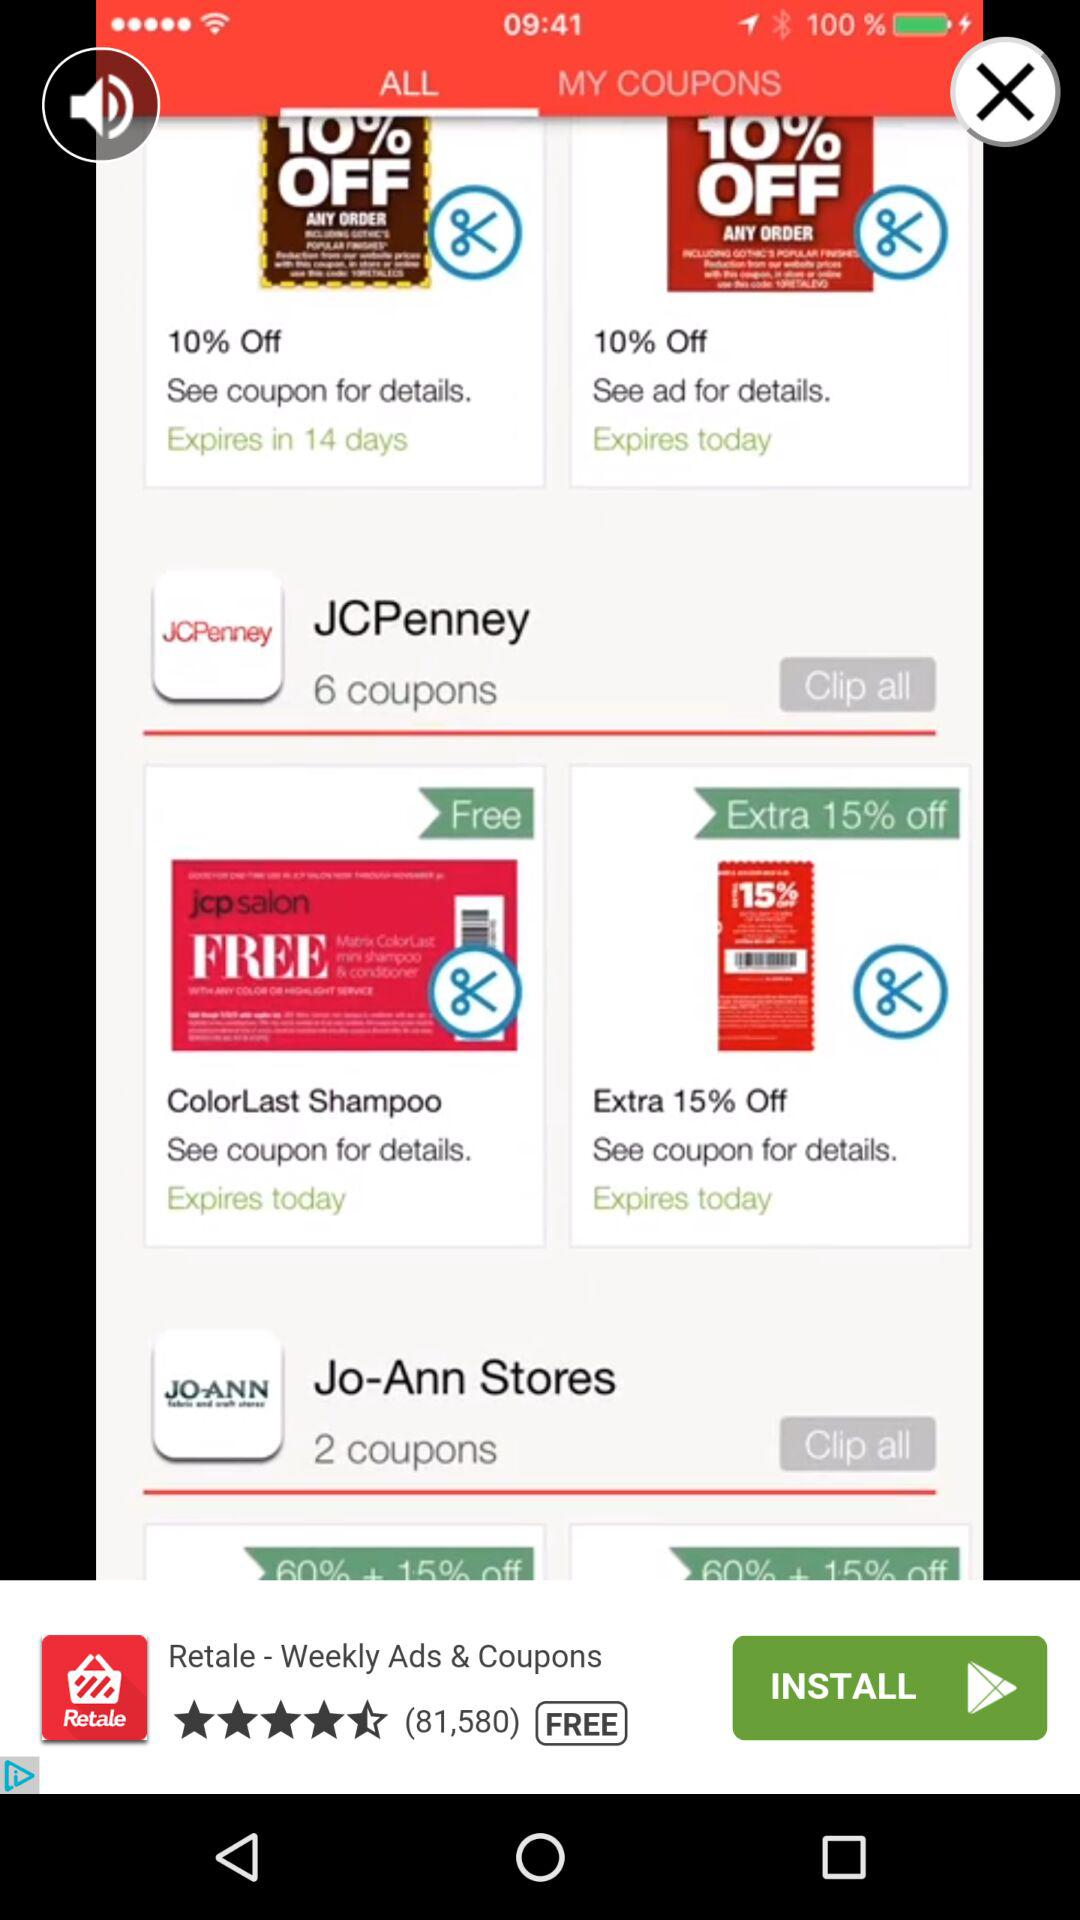How many "JCPenney" coupons are there? There are 6 "JCPenney" coupons. 